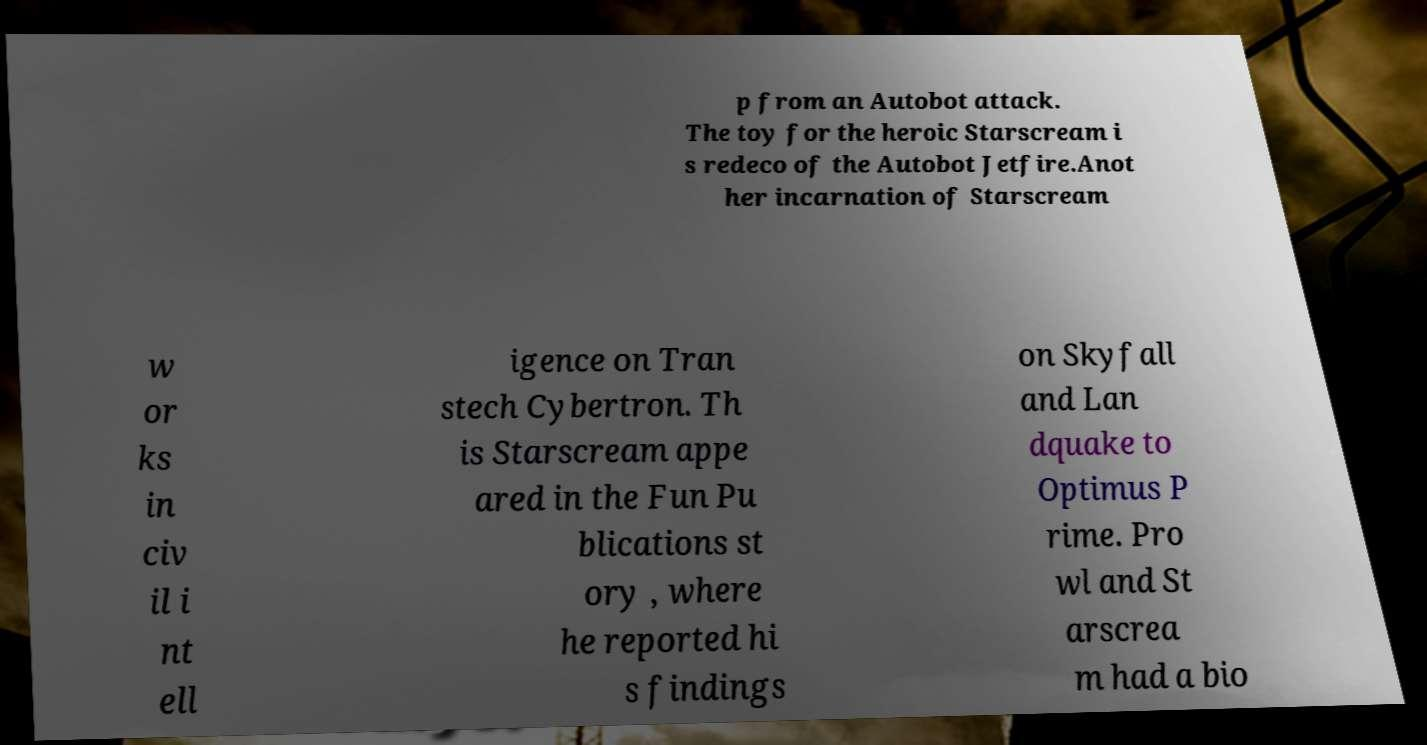Can you read and provide the text displayed in the image?This photo seems to have some interesting text. Can you extract and type it out for me? p from an Autobot attack. The toy for the heroic Starscream i s redeco of the Autobot Jetfire.Anot her incarnation of Starscream w or ks in civ il i nt ell igence on Tran stech Cybertron. Th is Starscream appe ared in the Fun Pu blications st ory , where he reported hi s findings on Skyfall and Lan dquake to Optimus P rime. Pro wl and St arscrea m had a bio 